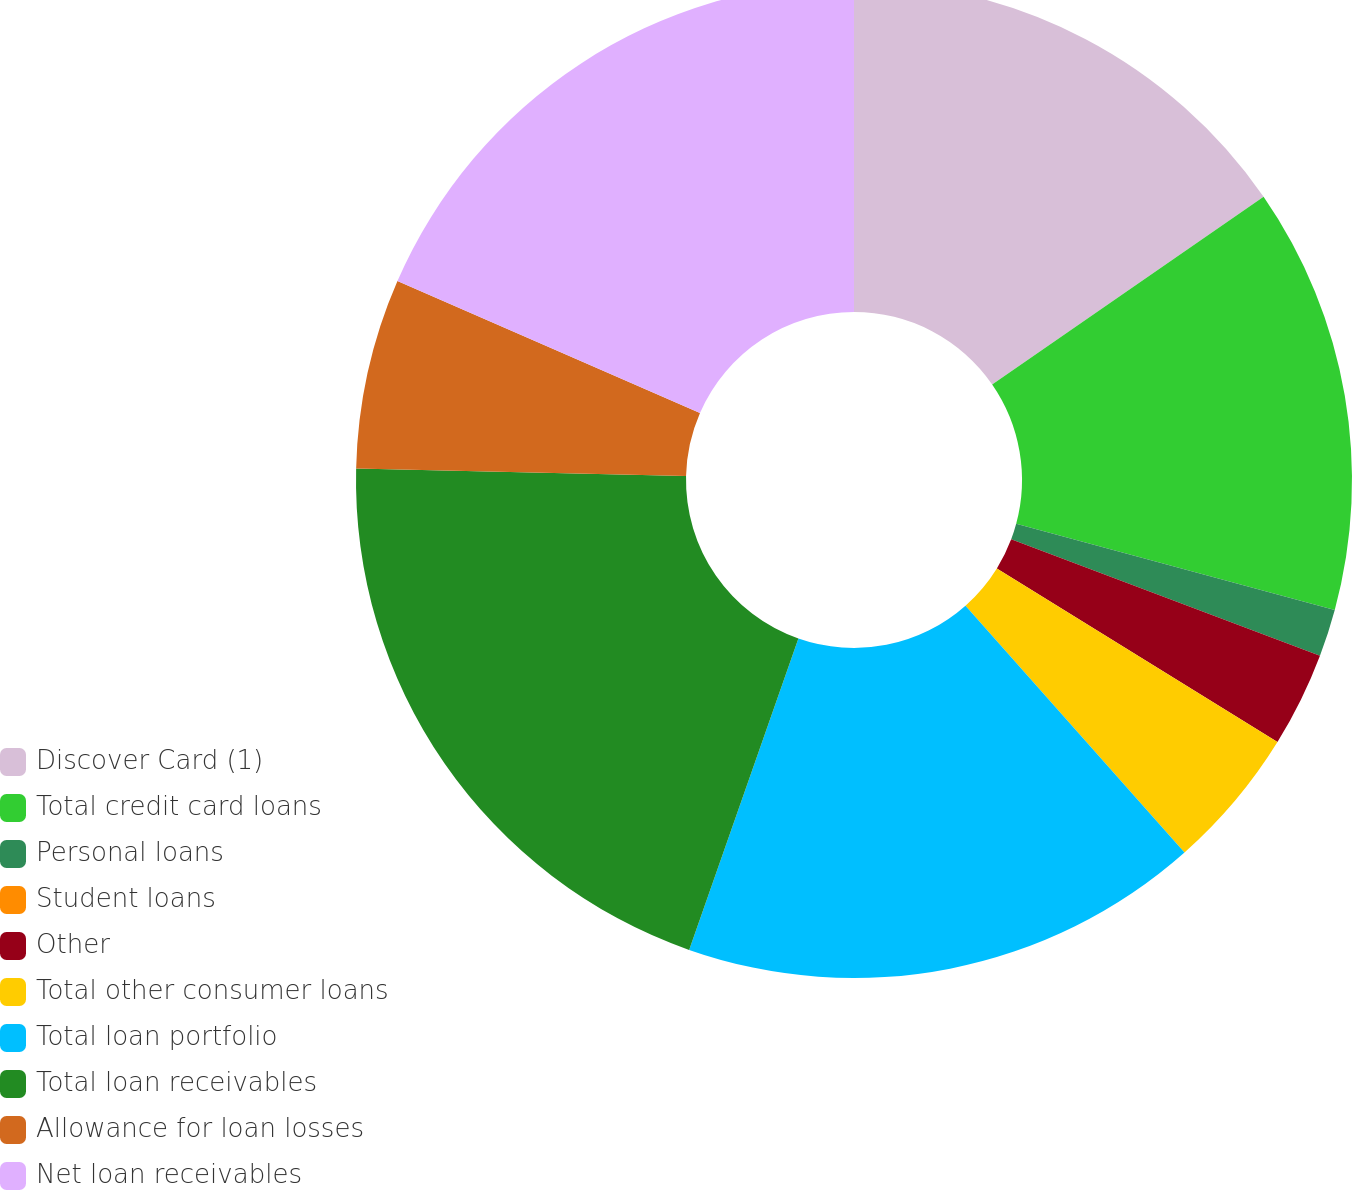<chart> <loc_0><loc_0><loc_500><loc_500><pie_chart><fcel>Discover Card (1)<fcel>Total credit card loans<fcel>Personal loans<fcel>Student loans<fcel>Other<fcel>Total other consumer loans<fcel>Total loan portfolio<fcel>Total loan receivables<fcel>Allowance for loan losses<fcel>Net loan receivables<nl><fcel>15.37%<fcel>13.83%<fcel>1.54%<fcel>0.0%<fcel>3.08%<fcel>4.63%<fcel>16.92%<fcel>20.0%<fcel>6.17%<fcel>18.46%<nl></chart> 